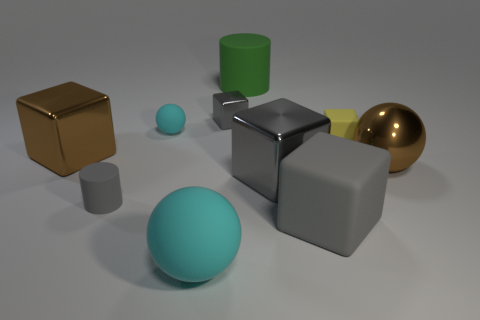There is a gray matte thing to the right of the green rubber object; is it the same size as the small cyan matte thing?
Offer a terse response. No. What number of other things are the same shape as the large gray rubber thing?
Make the answer very short. 4. Is the color of the large matte object behind the small yellow matte block the same as the small rubber cylinder?
Give a very brief answer. No. Is there a shiny sphere of the same color as the big matte cylinder?
Give a very brief answer. No. There is a small matte cube; what number of small rubber objects are to the left of it?
Provide a short and direct response. 2. How many other objects are there of the same size as the green matte thing?
Offer a terse response. 5. Are the small block that is to the left of the large green matte cylinder and the cylinder that is in front of the tiny yellow block made of the same material?
Make the answer very short. No. There is another cube that is the same size as the yellow rubber block; what is its color?
Your answer should be very brief. Gray. Is there anything else of the same color as the large matte cylinder?
Provide a succinct answer. No. There is a green thing that is behind the tiny block that is right of the gray block on the left side of the large green matte object; how big is it?
Your answer should be very brief. Large. 